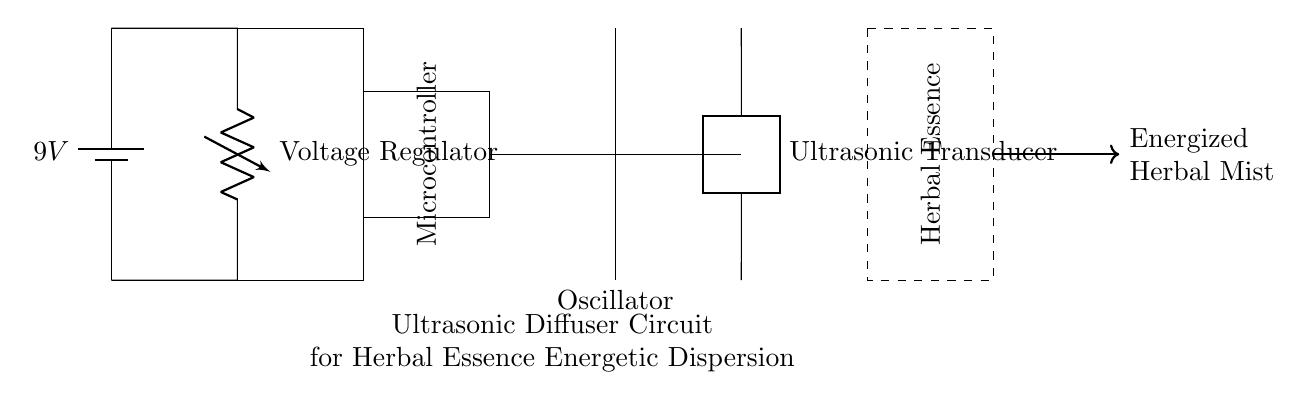What is the input voltage of the circuit? The input voltage is 9V, as indicated on the battery symbol in the circuit diagram.
Answer: 9V What component regulates the voltage in this circuit? The component that regulates the voltage is labeled as the Voltage Regulator, shown connected directly under the battery.
Answer: Voltage Regulator What is the function of the microcontroller in this circuit? The microcontroller's role is likely to control the operation of the oscillator and transducer based on programmed logic, although the exact function isn't specified in the diagram.
Answer: Control How is the ultrasonic transducer powered? The transducer is powered by the output of the oscillator, which connects to it directly; thus, it receives alternating signals to create ultrasonic vibrations.
Answer: Oscillator What is produced at the output of the diffuser? The output of the diffuser produces an energized herbal mist, as noted by the arrow pointing out of the container labeled "Herbal Essence."
Answer: Energized Herbal Mist What type of circuit is depicted in this diagram? The circuit depicted is an ultrasonic diffuser circuit specifically designed for dispersing herbal essences.
Answer: Ultrasonic diffuser What is the orientation of the herbal essence container in the circuit? The herbal essence container is oriented vertically, as indicated by the height of the dashed rectangle surrounding it and the label rotated to match that orientation.
Answer: Vertical 